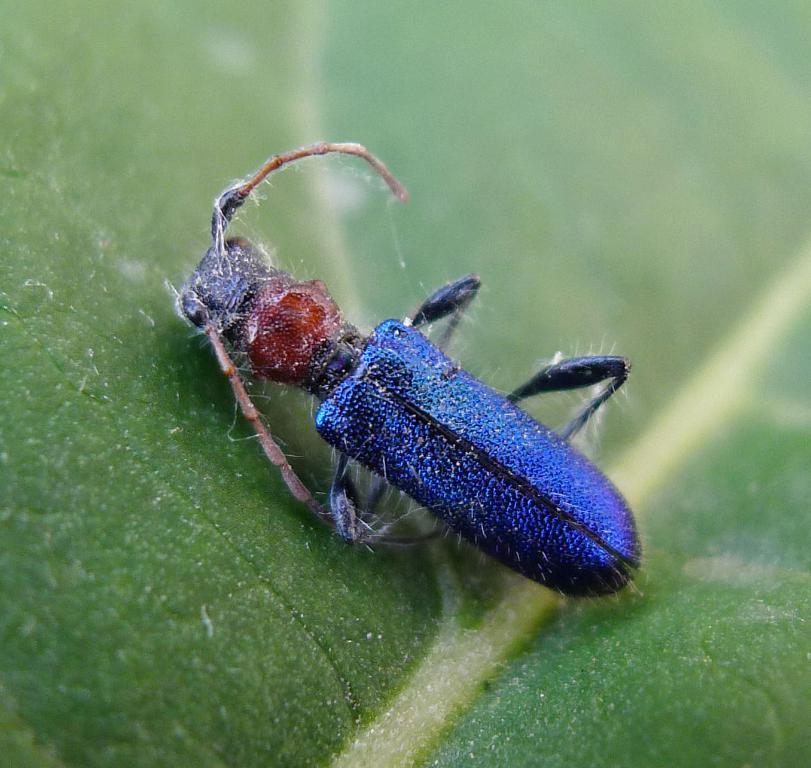What type of creature is present in the image? There is an insect in the image. Where is the insect located in the image? The insect is on a leaf. How many rabbits can be seen in the image? There are no rabbits present in the image. What is the insect using to taste the leaf in the image? Insects do not have tongues like humans, so they do not use a tongue to taste the leaf in the image. 